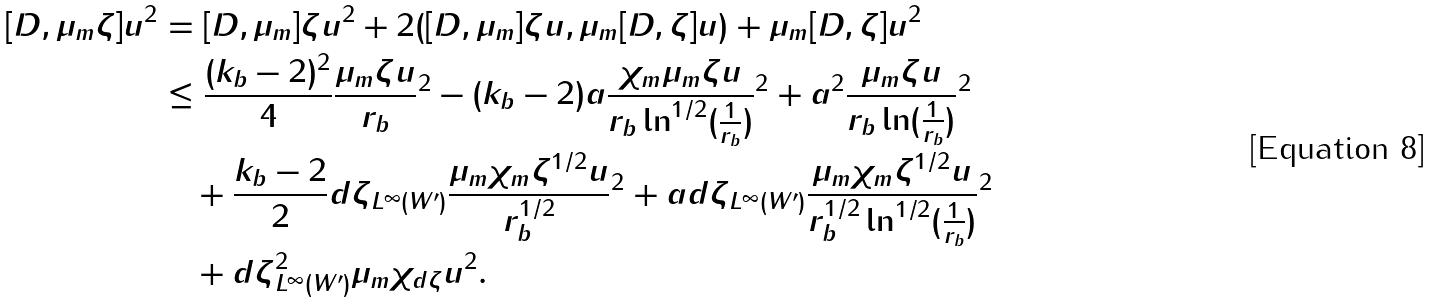Convert formula to latex. <formula><loc_0><loc_0><loc_500><loc_500>\| [ D , \mu _ { m } \zeta ] u \| ^ { 2 } & = \| [ D , \mu _ { m } ] \zeta u \| ^ { 2 } + 2 ( [ D , \mu _ { m } ] \zeta u , \mu _ { m } [ D , \zeta ] u ) + \| \mu _ { m } [ D , \zeta ] u \| ^ { 2 } \\ & \leq \frac { ( k _ { b } - 2 ) ^ { 2 } } { 4 } \| \frac { \mu _ { m } \zeta u } { r _ { b } } \| ^ { 2 } - ( k _ { b } - 2 ) a \| \frac { \chi _ { m } \mu _ { m } \zeta u } { r _ { b } \ln ^ { 1 / 2 } ( \frac { 1 } { r _ { b } } ) } \| ^ { 2 } + a ^ { 2 } \| \frac { \mu _ { m } \zeta u } { r _ { b } \ln ( \frac { 1 } { r _ { b } } ) } \| ^ { 2 } \\ & \quad + \frac { k _ { b } - 2 } { 2 } \| d \zeta \| _ { L ^ { \infty } ( W ^ { \prime } ) } \| \frac { \mu _ { m } \chi _ { m } \zeta ^ { 1 / 2 } u } { r _ { b } ^ { 1 / 2 } } \| ^ { 2 } + a \| d \zeta \| _ { L ^ { \infty } ( W ^ { \prime } ) } \| \frac { \mu _ { m } \chi _ { m } \zeta ^ { 1 / 2 } u } { r _ { b } ^ { 1 / 2 } \ln ^ { 1 / 2 } ( \frac { 1 } { r _ { b } } ) } \| ^ { 2 } \\ & \quad + \| d \zeta \| _ { L ^ { \infty } ( W ^ { \prime } ) } ^ { 2 } \| \mu _ { m } \chi _ { d \zeta } u \| ^ { 2 } .</formula> 